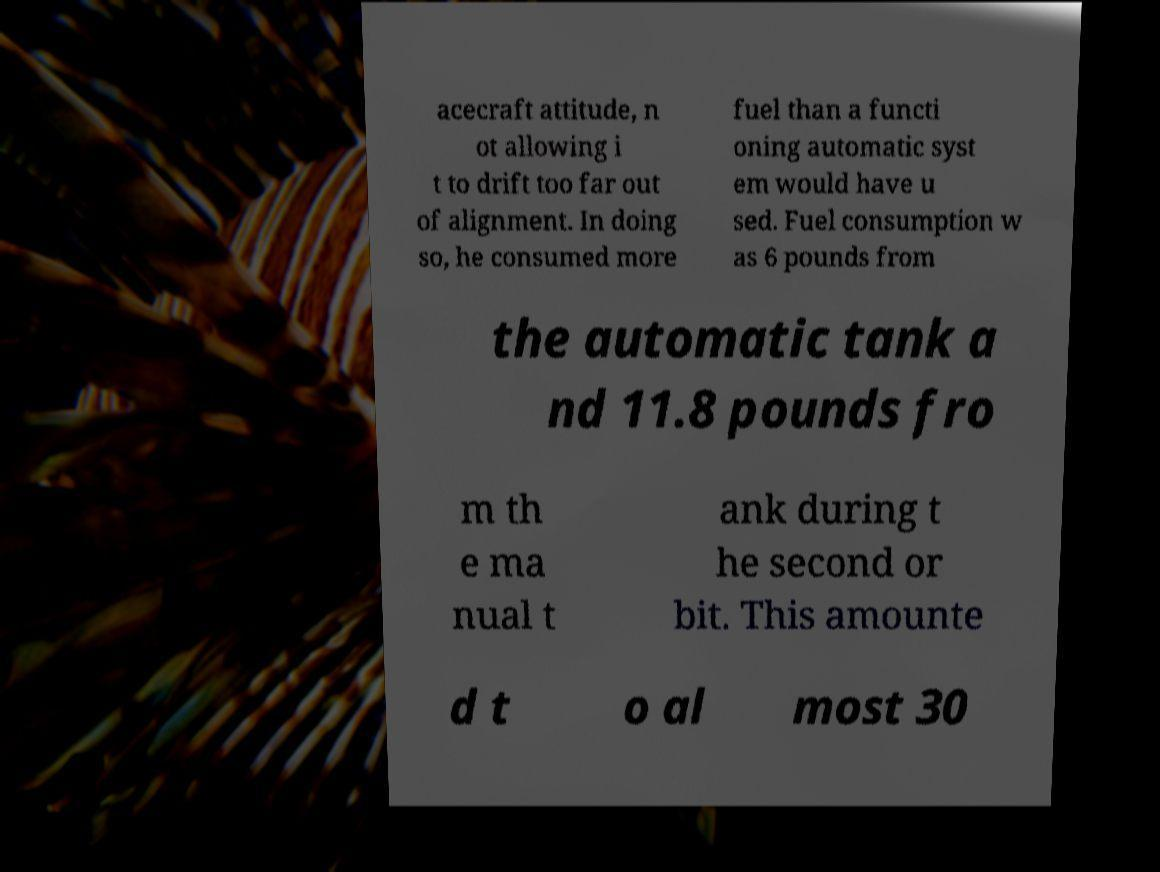There's text embedded in this image that I need extracted. Can you transcribe it verbatim? acecraft attitude, n ot allowing i t to drift too far out of alignment. In doing so, he consumed more fuel than a functi oning automatic syst em would have u sed. Fuel consumption w as 6 pounds from the automatic tank a nd 11.8 pounds fro m th e ma nual t ank during t he second or bit. This amounte d t o al most 30 